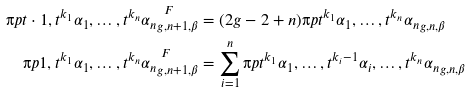Convert formula to latex. <formula><loc_0><loc_0><loc_500><loc_500>\i p { t \cdot 1 , t ^ { k _ { 1 } } \alpha _ { 1 } , \dots , t ^ { k _ { n } } \alpha _ { n } } ^ { \ F } _ { g , n + 1 , \beta } & = ( 2 g - 2 + n ) \i p { t ^ { k _ { 1 } } \alpha _ { 1 } , \dots , t ^ { k _ { n } } \alpha _ { n } } _ { g , n , \beta } \\ \i p { 1 , t ^ { k _ { 1 } } \alpha _ { 1 } , \dots , t ^ { k _ { n } } \alpha _ { n } } ^ { \ F } _ { g , n + 1 , \beta } & = \sum _ { i = 1 } ^ { n } \i p { t ^ { k _ { 1 } } \alpha _ { 1 } , \dots , t ^ { k _ { i } - 1 } \alpha _ { i } , \dots , t ^ { k _ { n } } \alpha _ { n } } _ { g , n , \beta }</formula> 